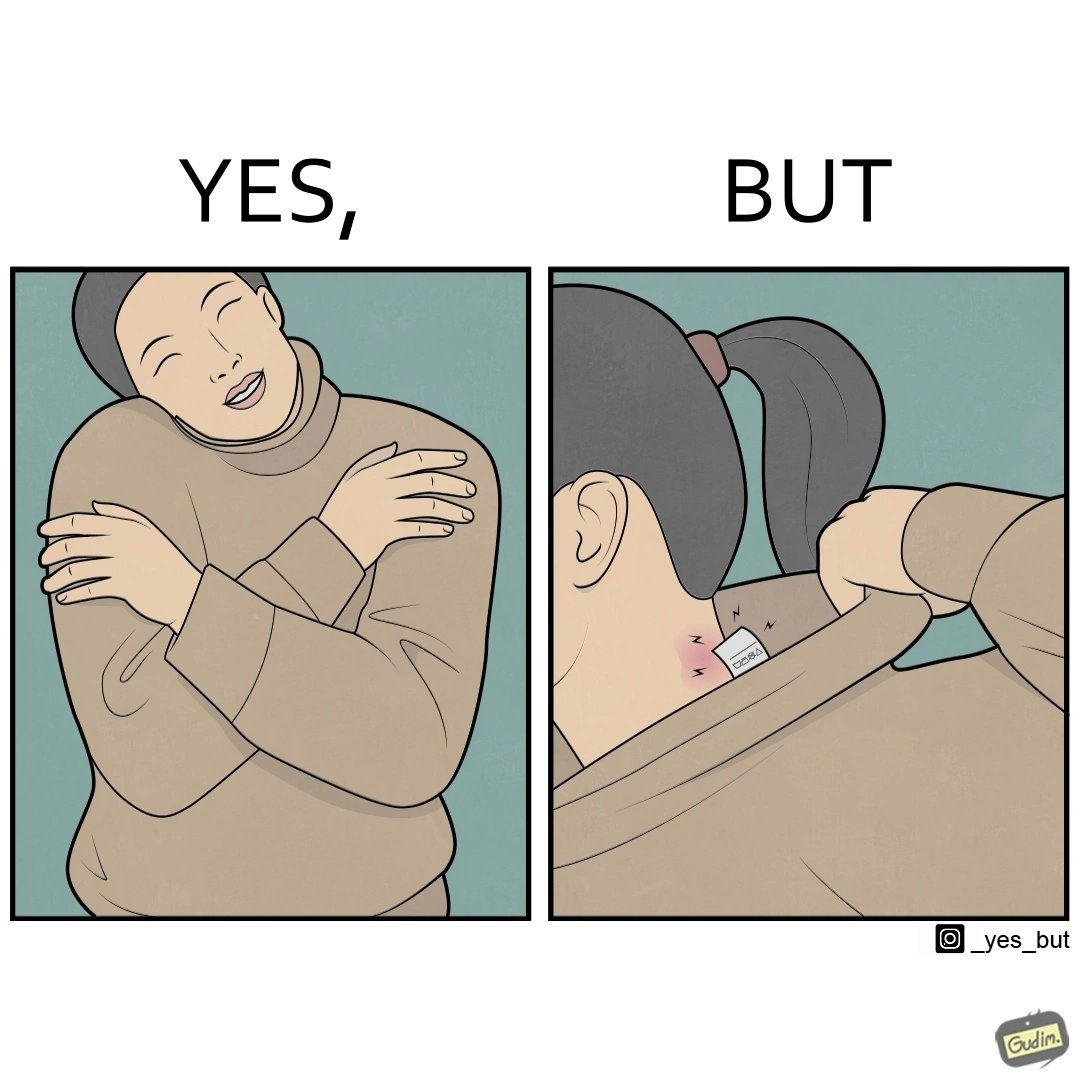Provide a description of this image. The images are funny since it shows how even though sweaters and other clothings provide much comfort, a tiny manufacturers tag ends up causing the user a lot of discomfort due to constant scratching 